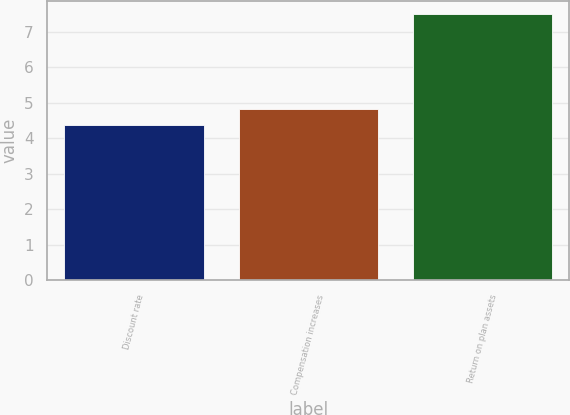Convert chart to OTSL. <chart><loc_0><loc_0><loc_500><loc_500><bar_chart><fcel>Discount rate<fcel>Compensation increases<fcel>Return on plan assets<nl><fcel>4.38<fcel>4.83<fcel>7.5<nl></chart> 